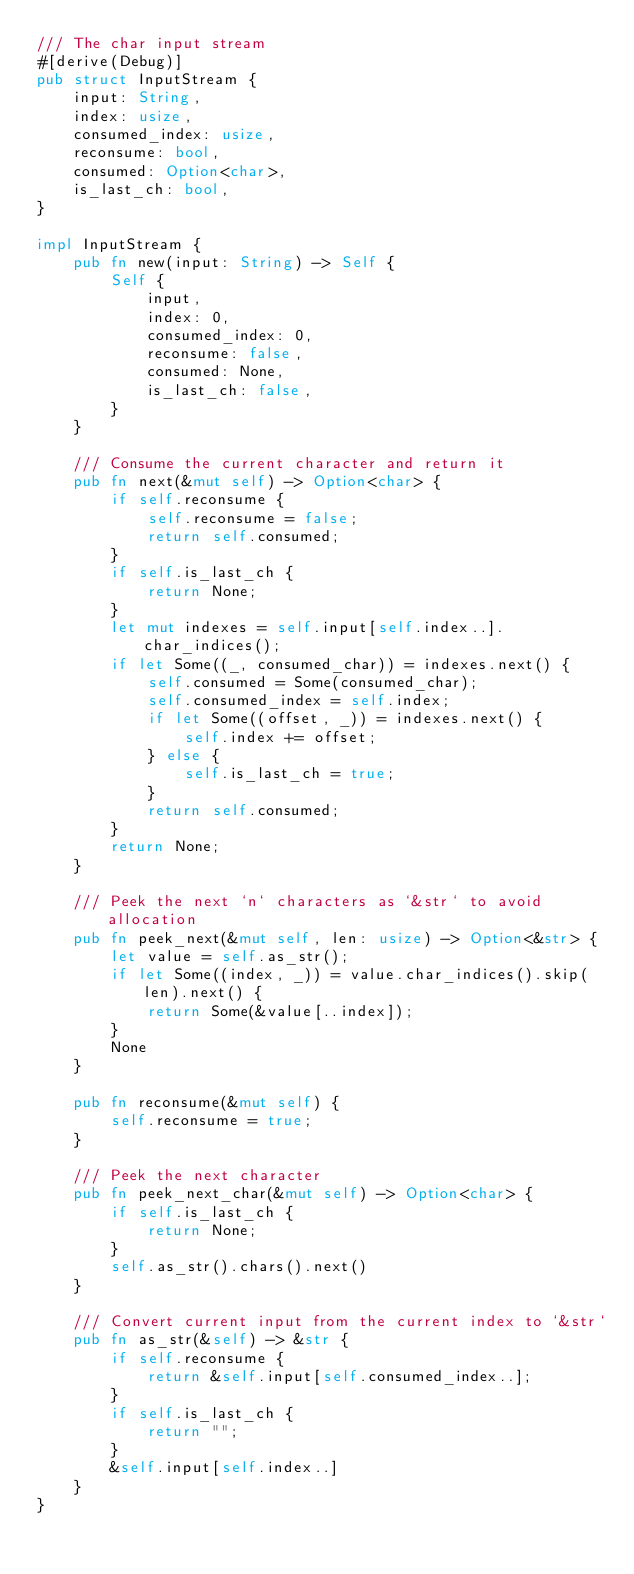<code> <loc_0><loc_0><loc_500><loc_500><_Rust_>/// The char input stream
#[derive(Debug)]
pub struct InputStream {
    input: String,
    index: usize,
    consumed_index: usize,
    reconsume: bool,
    consumed: Option<char>,
    is_last_ch: bool,
}

impl InputStream {
    pub fn new(input: String) -> Self {
        Self {
            input,
            index: 0,
            consumed_index: 0,
            reconsume: false,
            consumed: None,
            is_last_ch: false,
        }
    }

    /// Consume the current character and return it
    pub fn next(&mut self) -> Option<char> {
        if self.reconsume {
            self.reconsume = false;
            return self.consumed;
        }
        if self.is_last_ch {
            return None;
        }
        let mut indexes = self.input[self.index..].char_indices();
        if let Some((_, consumed_char)) = indexes.next() {
            self.consumed = Some(consumed_char);
            self.consumed_index = self.index;
            if let Some((offset, _)) = indexes.next() {
                self.index += offset;
            } else {
                self.is_last_ch = true;
            }
            return self.consumed;
        }
        return None;
    }

    /// Peek the next `n` characters as `&str` to avoid allocation
    pub fn peek_next(&mut self, len: usize) -> Option<&str> {
        let value = self.as_str();
        if let Some((index, _)) = value.char_indices().skip(len).next() {
            return Some(&value[..index]);
        }
        None
    }

    pub fn reconsume(&mut self) {
        self.reconsume = true;
    }

    /// Peek the next character
    pub fn peek_next_char(&mut self) -> Option<char> {
        if self.is_last_ch {
            return None;
        }
        self.as_str().chars().next()
    }

    /// Convert current input from the current index to `&str`
    pub fn as_str(&self) -> &str {
        if self.reconsume {
            return &self.input[self.consumed_index..];
        }
        if self.is_last_ch {
            return "";
        }
        &self.input[self.index..]
    }
}
</code> 